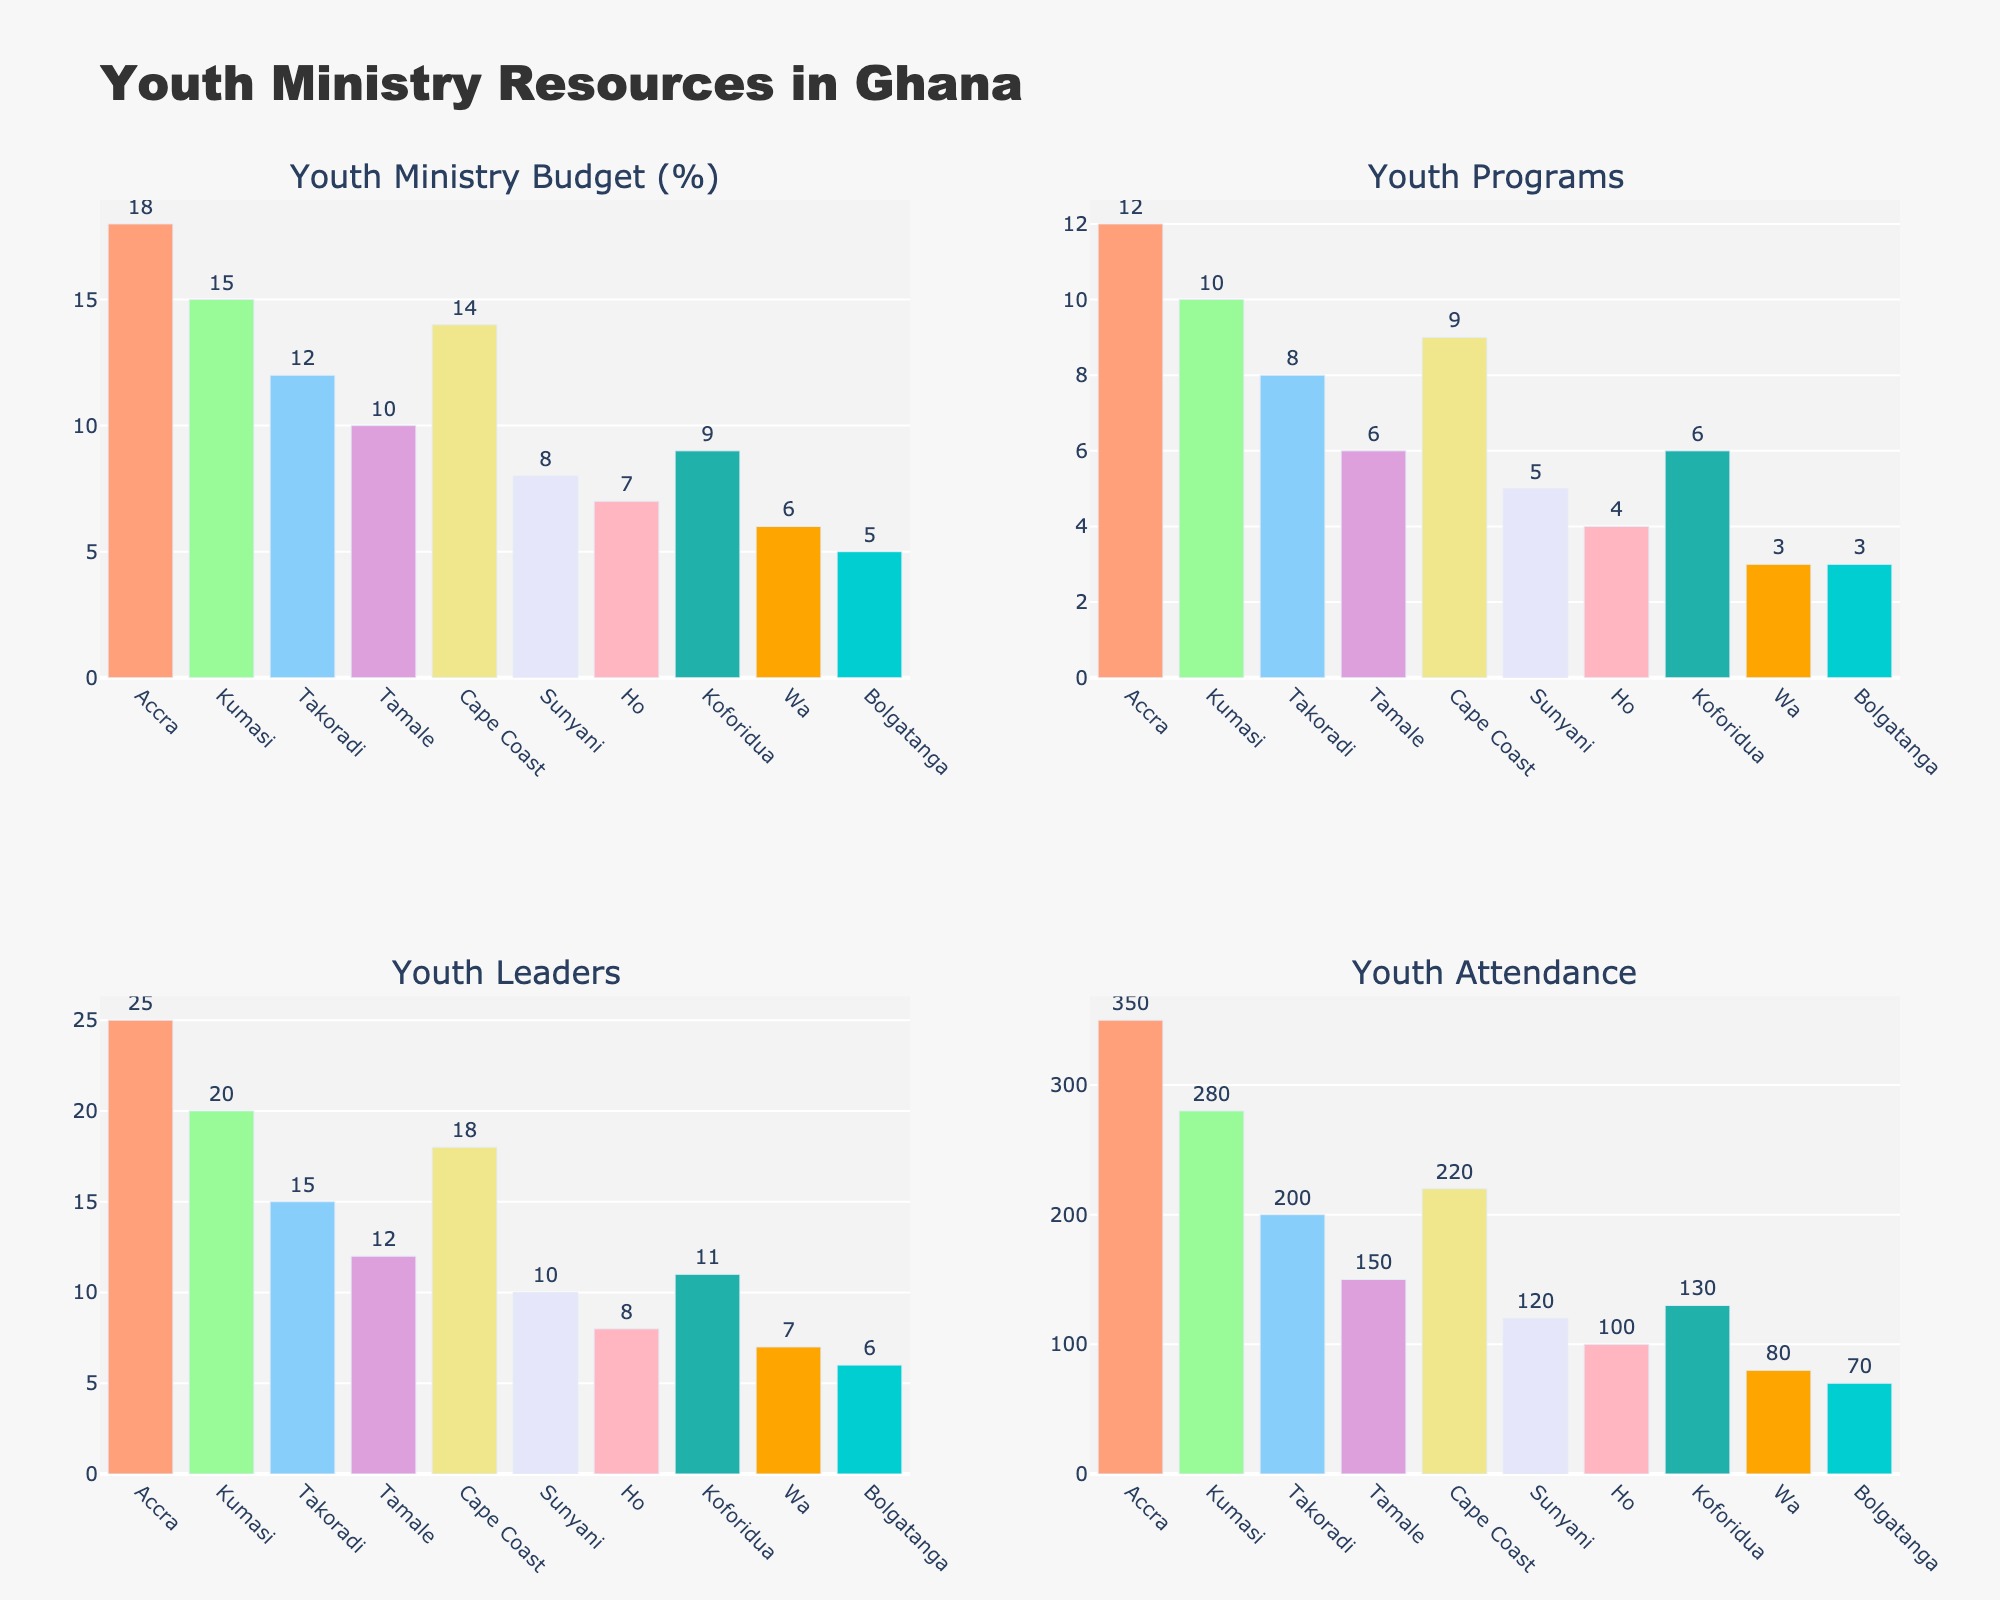How many areas are represented in the plot? The x-axis across all subplots shows the name of each area. To find the number of areas, we simply count these names.
Answer: 10 Which area has the highest budget allocation for youth ministry? Look at the subplot titled "Youth Ministry Budget (%)". Identify the bar with the greatest height, which corresponds to the area with the highest budget allocation.
Answer: Accra What is the total youth attendance in Takoradi and Cape Coast combined? Look at the subplot titled "Youth Attendance". Find the values for Takoradi and Cape Coast, and add them: 200 (Takoradi) + 220 (Cape Coast).
Answer: 420 Which areas have more than 200 youth attending their programs? Refer to the "Youth Attendance" subplot and identify the bars exceeding 200. The only bars are for Accra and Kumasi.
Answer: Accra, Kumasi Compare the number of youth programs between Sunyani and Ho. Look at the subplot titled "Youth Programs". Compare the bars for Sunyani and Ho. Sunyani has a value of 5 while Ho has 4.
Answer: Sunyani has more How does the youth attendance in Accra compare to that in Wa? Refer to the "Youth Attendance" subplot. Accra has 350 attendances, while Wa has 80. Accra's attendance is significantly higher.
Answer: Accra > Wa Which area dedicates the smallest percentage of the budget to youth ministry? Observe the subplot titled "Youth Ministry Budget (%)". The shortest bar represents the smallest percentage; in this case, it's Bolgatanga with 5%.
Answer: Bolgatanga What is the average number of youth leaders across all areas? Look at the subplot titled "Youth Leaders". Sum all the values (25 + 20 + 15 + 12 + 18 + 10 + 8 + 11 + 7 + 6 = 132) and divide by the number of areas, which is 10. 132 / 10 = 13.2.
Answer: 13.2 Is there any area with an equal number of youth leaders and programs? Observe the subplots titled "Youth Programs" and "Youth Leaders". Scan through the values to find any matching pairs. There are none.
Answer: No What is the range of the youth ministry budget percentages across the areas? Identify the highest budget percentage from the "Youth Ministry Budget (%)" subplot, which is 18% (Accra), and the lowest, which is 5% (Bolgatanga). The range is 18% - 5% = 13%.
Answer: 13% 